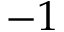<formula> <loc_0><loc_0><loc_500><loc_500>- 1</formula> 